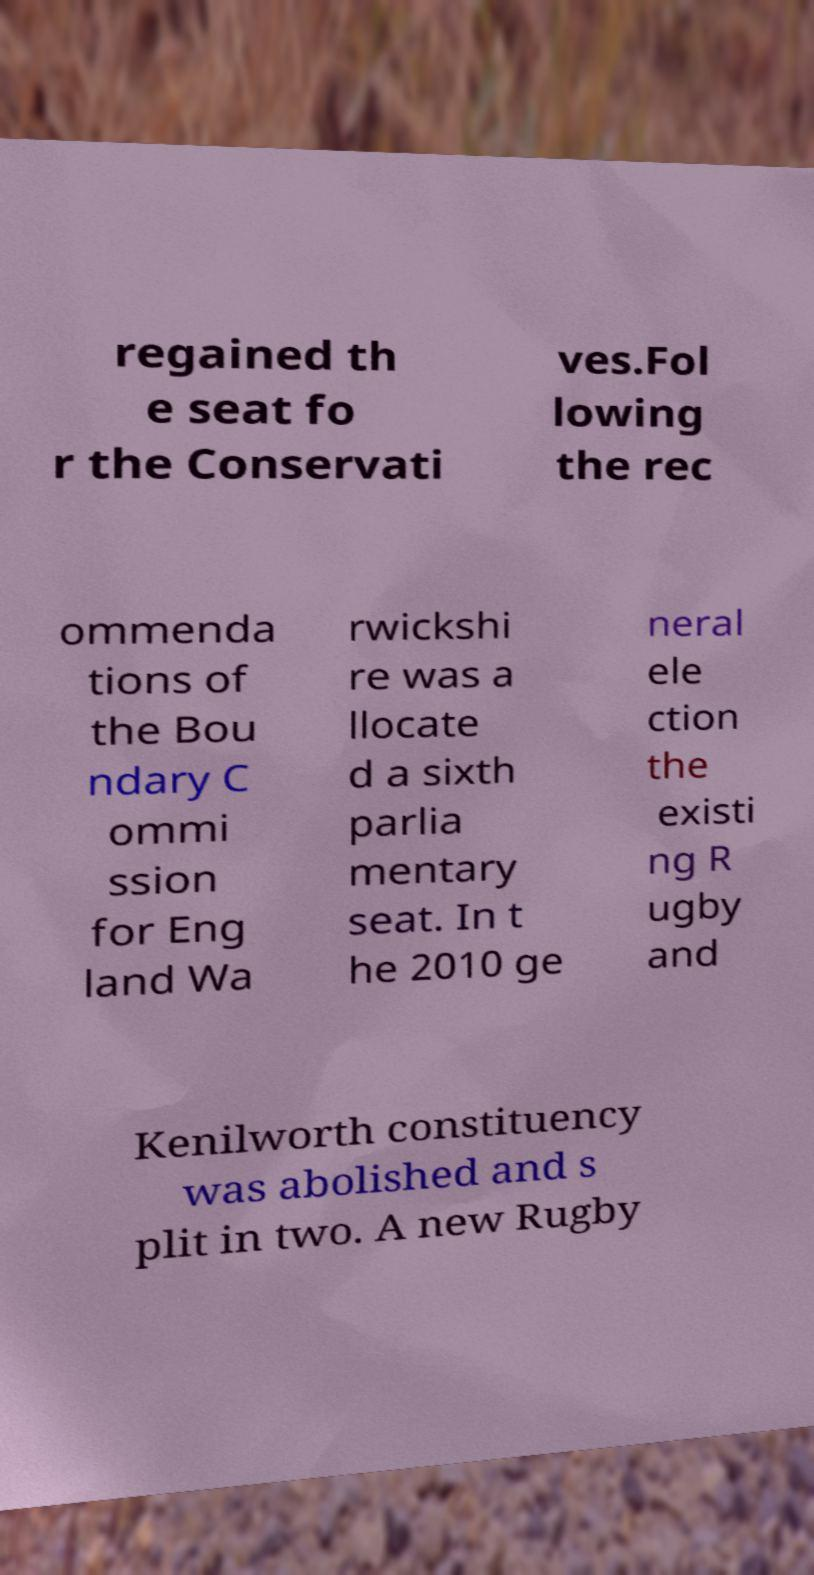I need the written content from this picture converted into text. Can you do that? regained th e seat fo r the Conservati ves.Fol lowing the rec ommenda tions of the Bou ndary C ommi ssion for Eng land Wa rwickshi re was a llocate d a sixth parlia mentary seat. In t he 2010 ge neral ele ction the existi ng R ugby and Kenilworth constituency was abolished and s plit in two. A new Rugby 